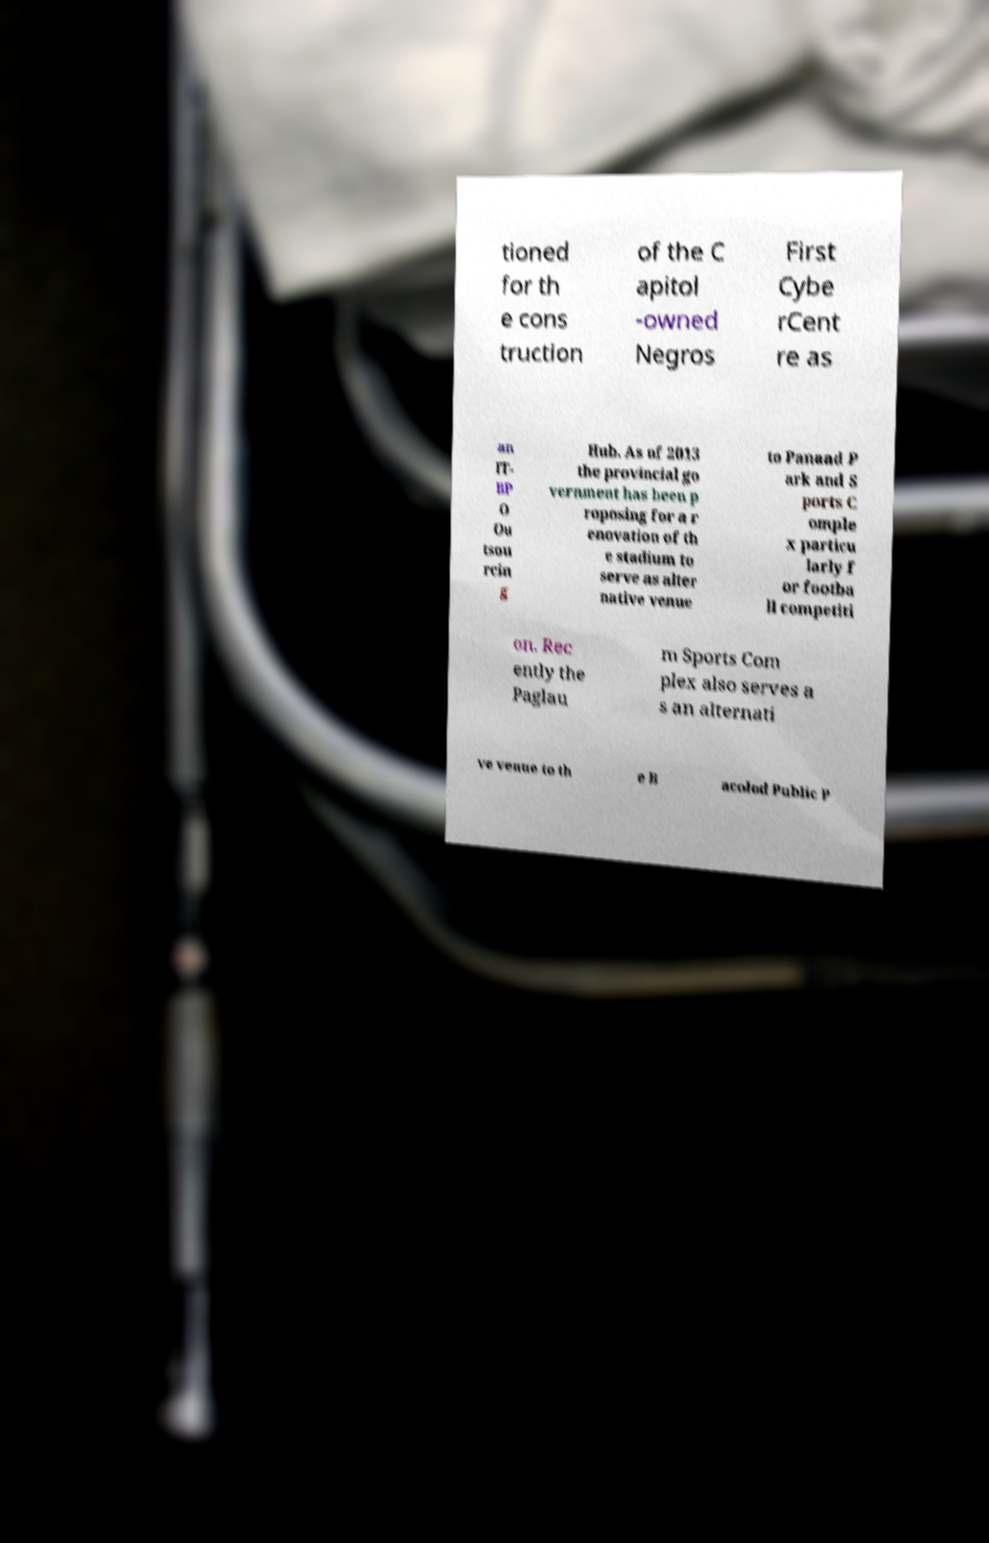Can you read and provide the text displayed in the image?This photo seems to have some interesting text. Can you extract and type it out for me? tioned for th e cons truction of the C apitol -owned Negros First Cybe rCent re as an IT- BP O Ou tsou rcin g Hub. As of 2013 the provincial go vernment has been p roposing for a r enovation of th e stadium to serve as alter native venue to Panaad P ark and S ports C omple x particu larly f or footba ll competiti on. Rec ently the Paglau m Sports Com plex also serves a s an alternati ve venue to th e B acolod Public P 